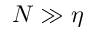<formula> <loc_0><loc_0><loc_500><loc_500>N \gg \eta</formula> 